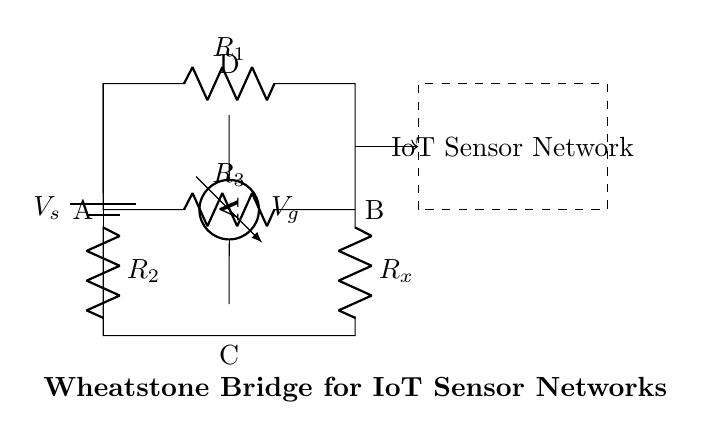What is the voltage source in this circuit? The voltage source is labeled V_s, which indicates the point of potential difference driving the current through the circuit.
Answer: V_s What are the resistors' labels in this Wheatstone bridge? The resistors are labeled R_1, R_2, R_3, and R_x, indicating their positions in the bridge configuration.
Answer: R_1, R_2, R_3, R_x What is the purpose of the voltmeter in the circuit? The voltmeter, denoted as V_g, is used to measure the voltage difference between points A and B, providing insights into the balance of the Wheatstone bridge.
Answer: Measure voltage How many resistors are in the Wheatstone bridge? The circuit contains four resistors: R_1, R_2, R_3, and R_x, which are essential for the bridge's function.
Answer: Four What does a balanced Wheatstone bridge indicate? A balanced Wheatstone bridge, where V_g equals zero, indicates that the ratio of the resistances R_1/R_2 equals R_x/R_3, allowing precise resistance measurement.
Answer: Precise resistance measurement What role does the IoT sensor network play in this circuit? The dashed rectangle indicates the integration area for the IoT sensor network, which can utilize the voltage measurement for various applications.
Answer: Integration area How is R_x positioned in the bridge? R_x is connected in series with R_3, while the other resistors R_1 and R_2 are arranged in parallel with each other, enabling the balance condition.
Answer: In series with R_3 